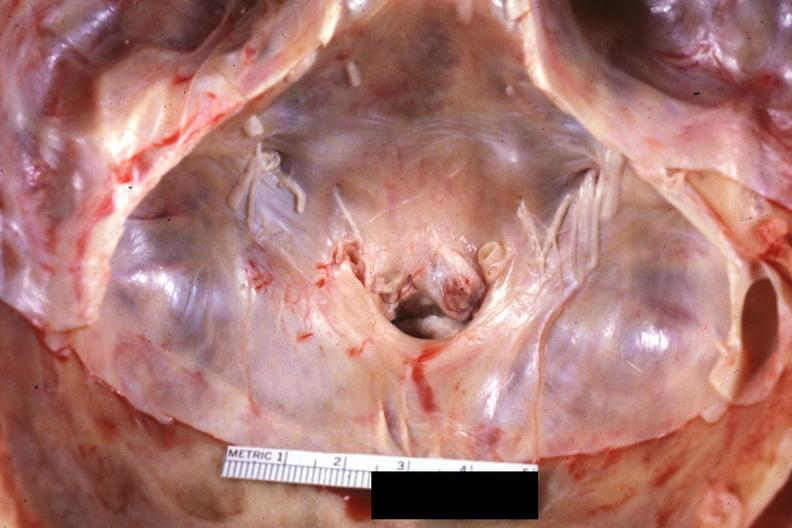does this image show close-up of foramen magnum stenosis due to subluxation of atlas vertebra case 31?
Answer the question using a single word or phrase. Yes 